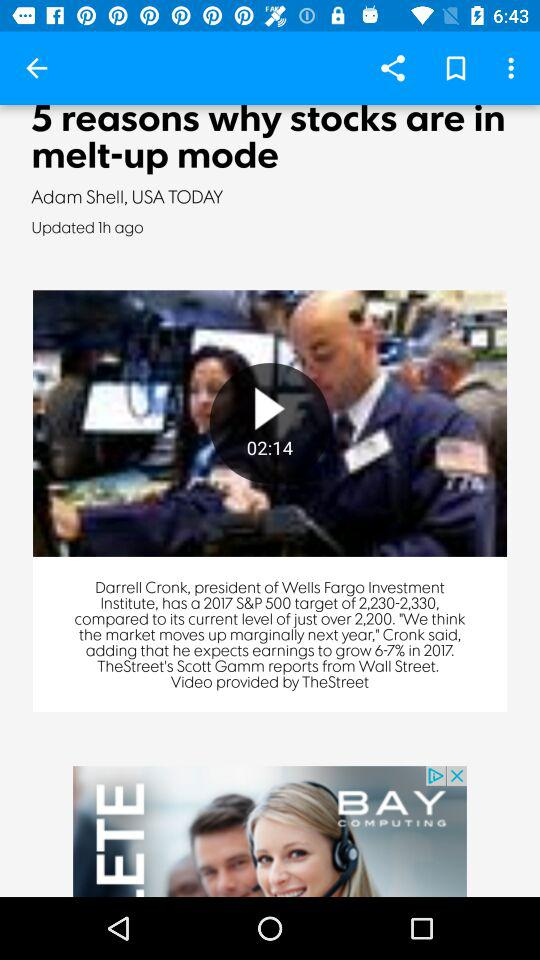What is the duration of the video? The duration of the video is 2 minutes and 14 seconds. 